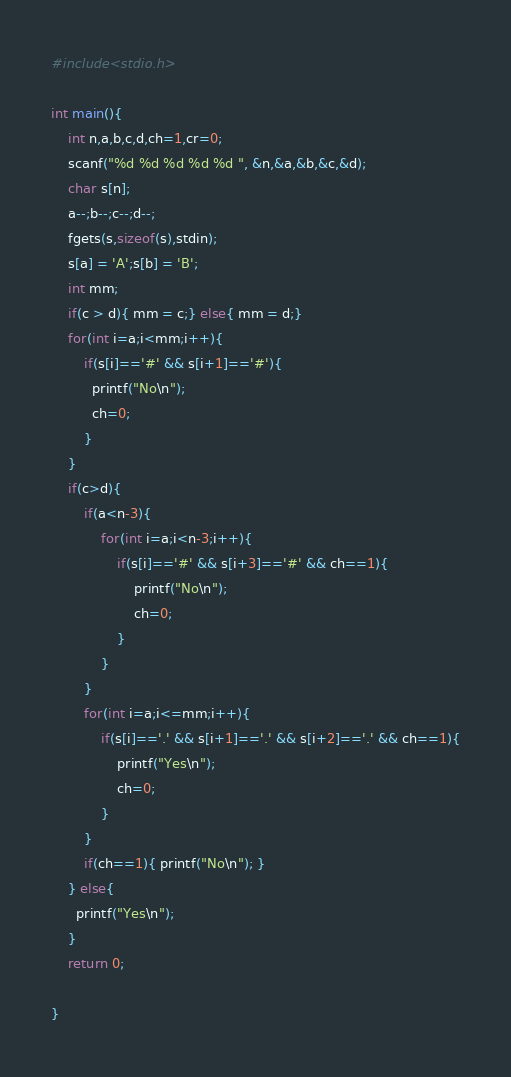Convert code to text. <code><loc_0><loc_0><loc_500><loc_500><_C_>#include<stdio.h>

int main(){
	int n,a,b,c,d,ch=1,cr=0;
  	scanf("%d %d %d %d %d ", &n,&a,&b,&c,&d);
  	char s[n];
  	a--;b--;c--;d--;
  	fgets(s,sizeof(s),stdin);
  	s[a] = 'A';s[b] = 'B';
  	int mm;
	if(c > d){ mm = c;} else{ mm = d;}
  	for(int i=a;i<mm;i++){
        if(s[i]=='#' && s[i+1]=='#'){
          printf("No\n");
          ch=0;
        }
    }
  	if(c>d){
		if(a<n-3){
      		for(int i=a;i<n-3;i++){ 
              	if(s[i]=='#' && s[i+3]=='#' && ch==1){
              		printf("No\n"); 
                  	ch=0;
                }
            }
        }
      	for(int i=a;i<=mm;i++){
        	if(s[i]=='.' && s[i+1]=='.' && s[i+2]=='.' && ch==1){
             	printf("Yes\n");
              	ch=0;
            }
        }
      	if(ch==1){ printf("No\n"); }
    } else{
      printf("Yes\n");
    }
  	return 0;
  
}</code> 